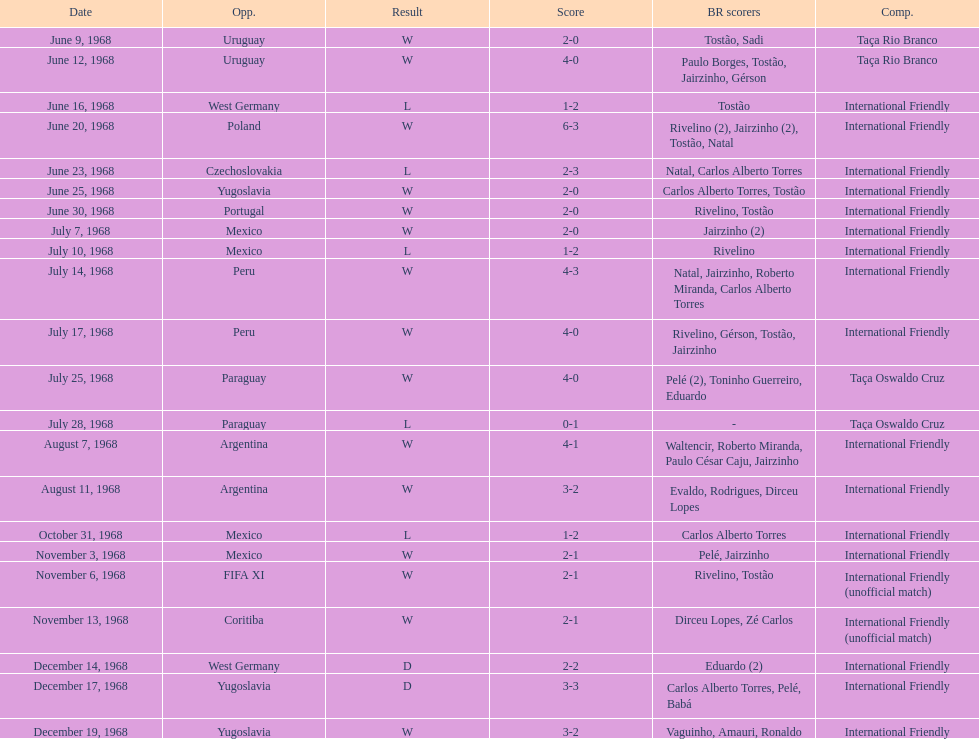How many goals did brazil make during the game on november 6th? 2. 